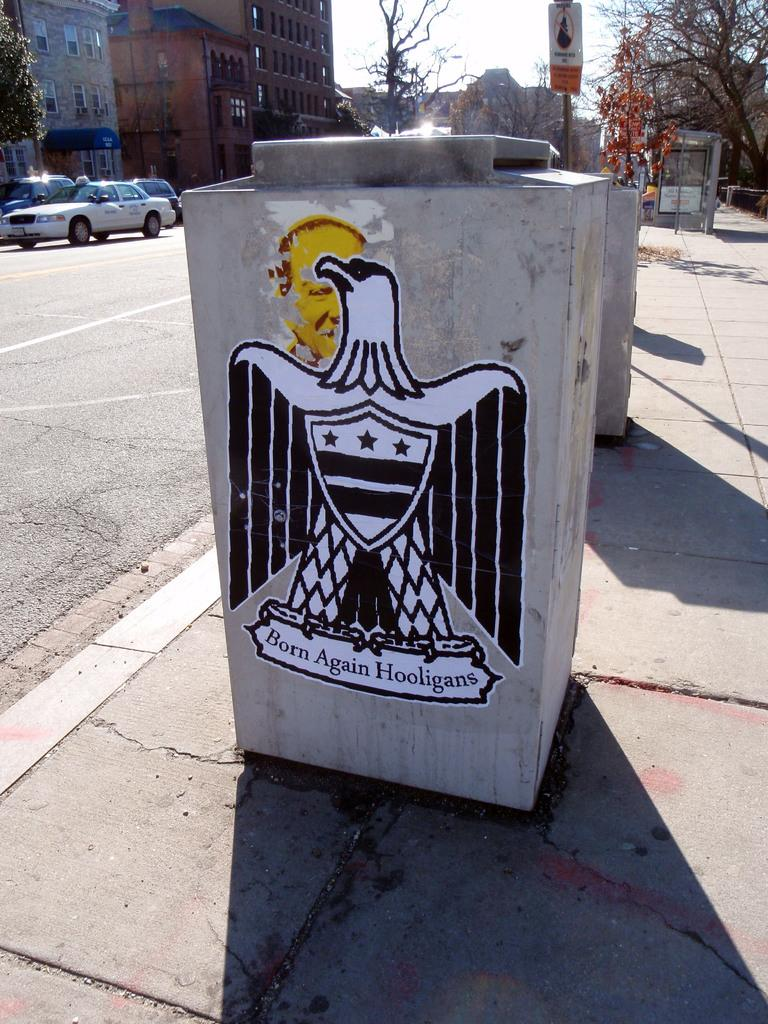<image>
Relay a brief, clear account of the picture shown. Born again hooligans appears below a bird on a trash bin. 